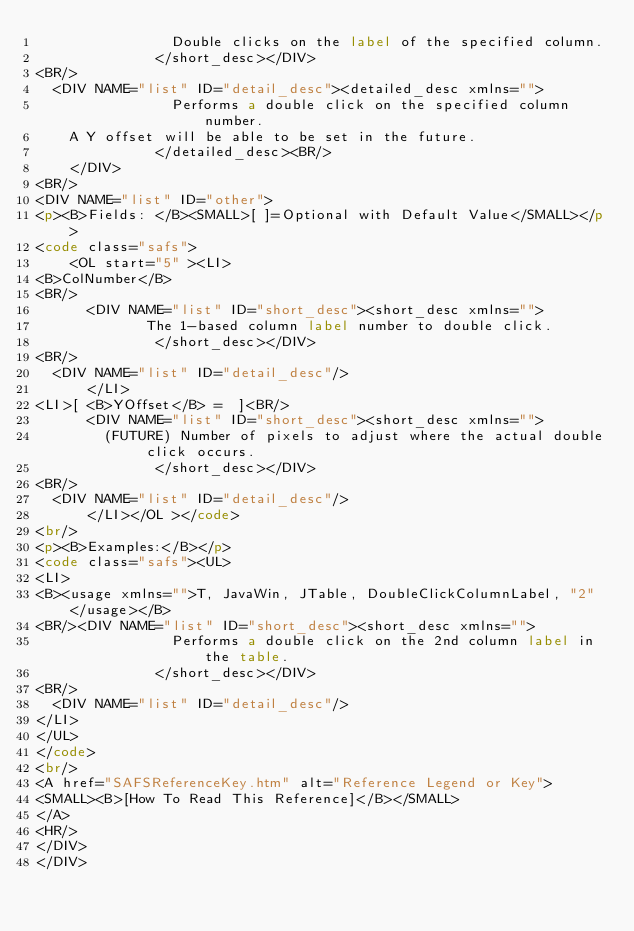<code> <loc_0><loc_0><loc_500><loc_500><_HTML_>                Double clicks on the label of the specified column.
              </short_desc></DIV>
<BR/>
	<DIV NAME="list" ID="detail_desc"><detailed_desc xmlns=""> 
                Performs a double click on the specified column number.
		A Y offset will be able to be set in the future.
              </detailed_desc><BR/>
		</DIV>
<BR/>
<DIV NAME="list" ID="other">
<p><B>Fields: </B><SMALL>[ ]=Optional with Default Value</SMALL></p>
<code class="safs">
	  <OL start="5" ><LI>
<B>ColNumber</B>
<BR/>
		  <DIV NAME="list" ID="short_desc"><short_desc xmlns="">
             The 1-based column label number to double click.
              </short_desc></DIV>
<BR/>
	<DIV NAME="list" ID="detail_desc"/>
		  </LI>
<LI>[ <B>YOffset</B> =  ]<BR/>
		  <DIV NAME="list" ID="short_desc"><short_desc xmlns=""> 
	      (FUTURE) Number of pixels to adjust where the actual double click occurs.
              </short_desc></DIV>
<BR/>
	<DIV NAME="list" ID="detail_desc"/>
		  </LI></OL ></code>
<br/>
<p><B>Examples:</B></p>
<code class="safs"><UL>
<LI>
<B><usage xmlns="">T, JavaWin, JTable, DoubleClickColumnLabel, "2"</usage></B>
<BR/><DIV NAME="list" ID="short_desc"><short_desc xmlns="">
                Performs a double click on the 2nd column label in the table.
              </short_desc></DIV>
<BR/>
	<DIV NAME="list" ID="detail_desc"/>
</LI>
</UL>
</code>
<br/>
<A href="SAFSReferenceKey.htm" alt="Reference Legend or Key">
<SMALL><B>[How To Read This Reference]</B></SMALL>
</A>
<HR/>
</DIV>
</DIV>
	</code> 